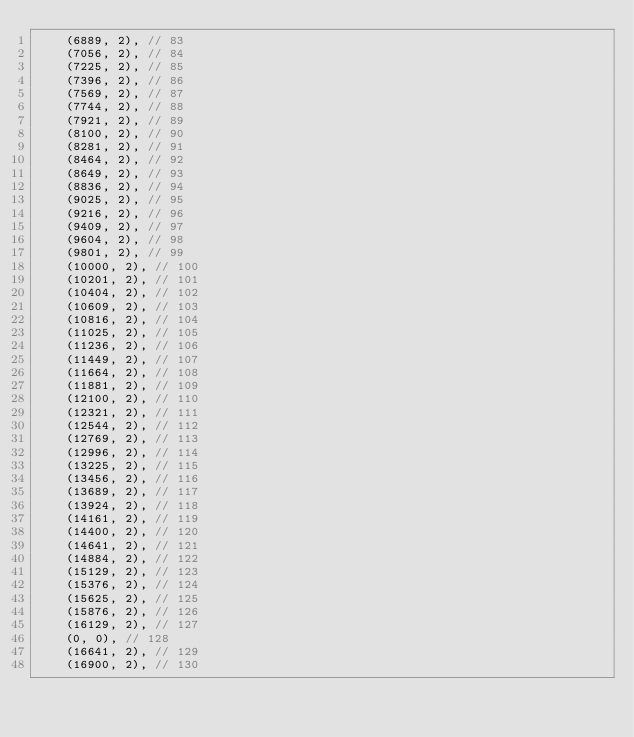<code> <loc_0><loc_0><loc_500><loc_500><_Rust_>    (6889, 2), // 83
    (7056, 2), // 84
    (7225, 2), // 85
    (7396, 2), // 86
    (7569, 2), // 87
    (7744, 2), // 88
    (7921, 2), // 89
    (8100, 2), // 90
    (8281, 2), // 91
    (8464, 2), // 92
    (8649, 2), // 93
    (8836, 2), // 94
    (9025, 2), // 95
    (9216, 2), // 96
    (9409, 2), // 97
    (9604, 2), // 98
    (9801, 2), // 99
    (10000, 2), // 100
    (10201, 2), // 101
    (10404, 2), // 102
    (10609, 2), // 103
    (10816, 2), // 104
    (11025, 2), // 105
    (11236, 2), // 106
    (11449, 2), // 107
    (11664, 2), // 108
    (11881, 2), // 109
    (12100, 2), // 110
    (12321, 2), // 111
    (12544, 2), // 112
    (12769, 2), // 113
    (12996, 2), // 114
    (13225, 2), // 115
    (13456, 2), // 116
    (13689, 2), // 117
    (13924, 2), // 118
    (14161, 2), // 119
    (14400, 2), // 120
    (14641, 2), // 121
    (14884, 2), // 122
    (15129, 2), // 123
    (15376, 2), // 124
    (15625, 2), // 125
    (15876, 2), // 126
    (16129, 2), // 127
    (0, 0), // 128
    (16641, 2), // 129
    (16900, 2), // 130</code> 